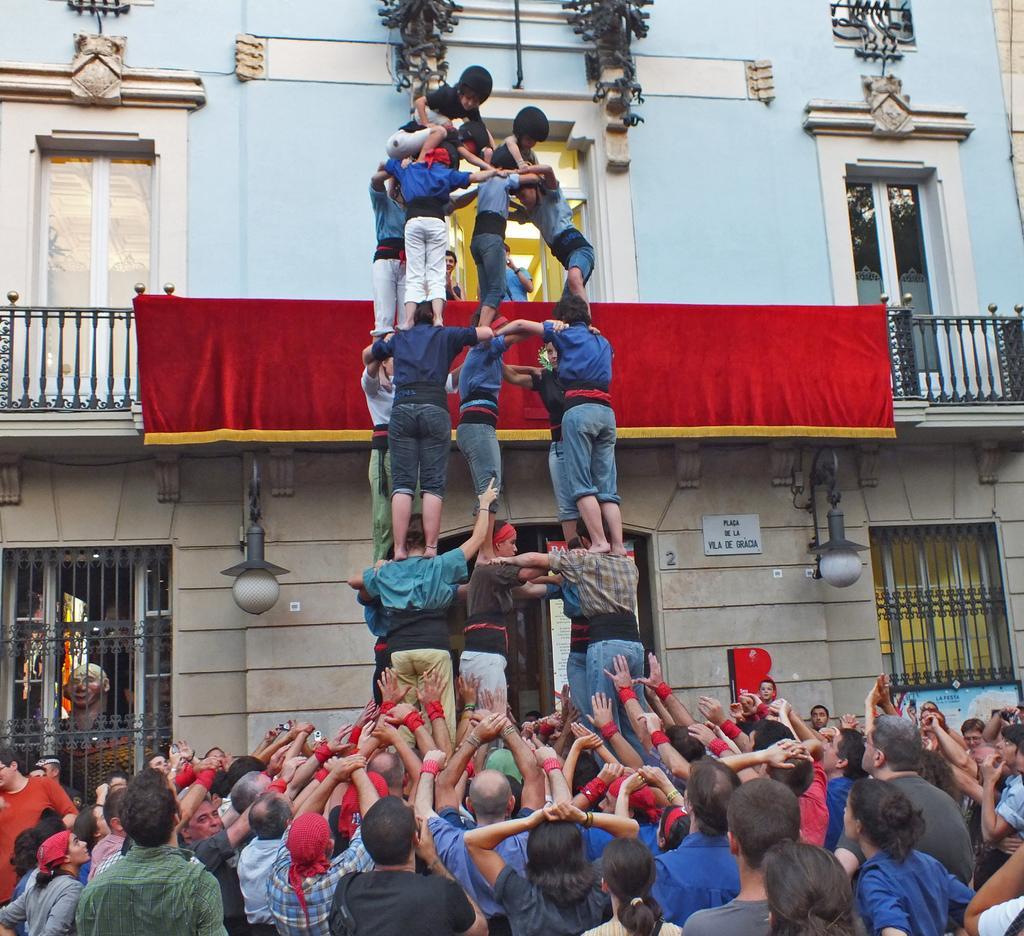Can you describe this image briefly? In the picture we can see a group of people standing and some people are doing some stunts by standing with some people with each other, in the background, we can see a house building with walls, windows and doors and some railing. 